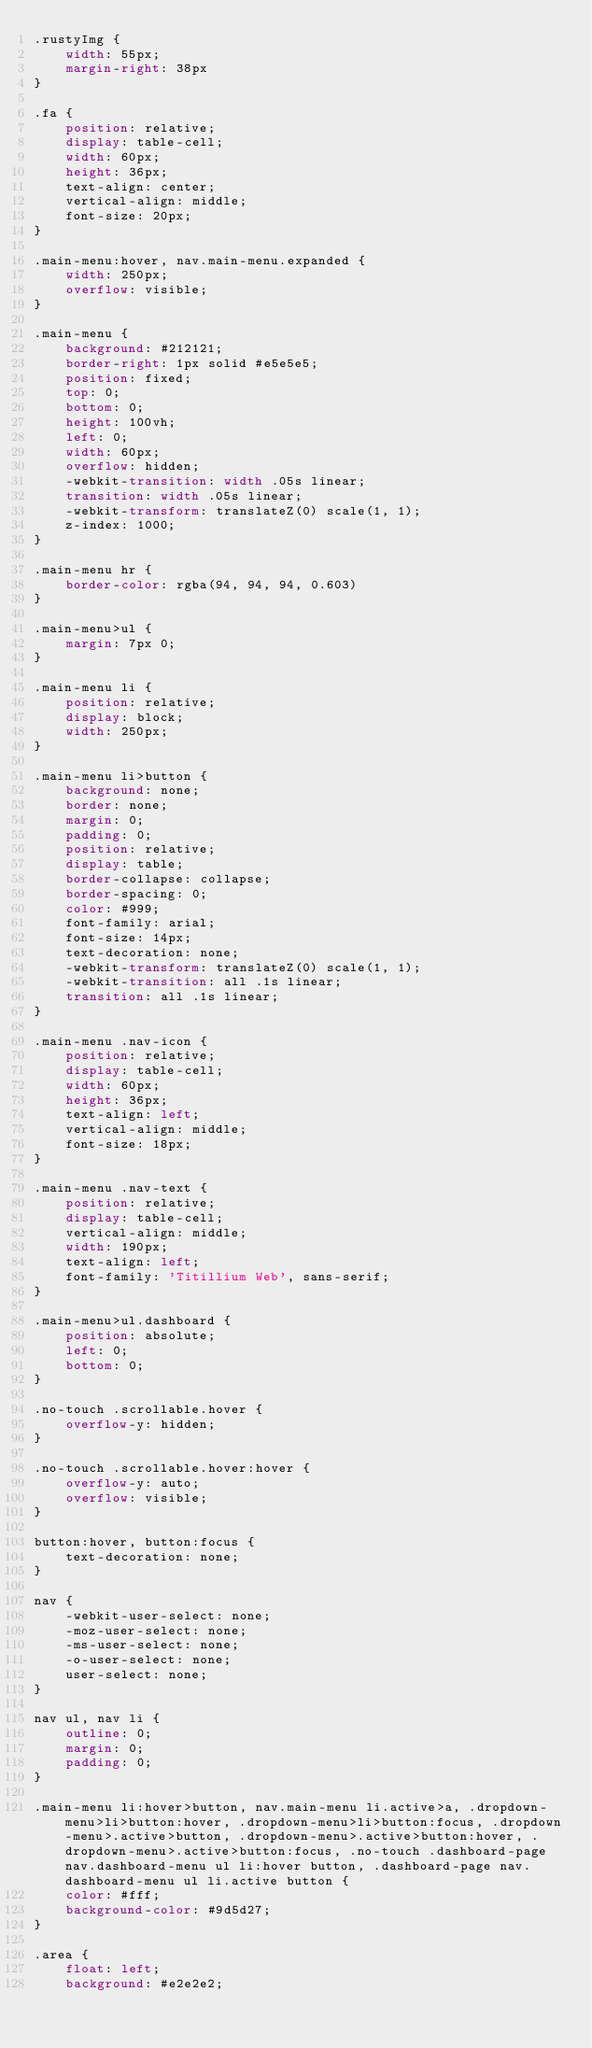<code> <loc_0><loc_0><loc_500><loc_500><_CSS_>.rustyImg {
    width: 55px;
    margin-right: 38px
}

.fa {
    position: relative;
    display: table-cell;
    width: 60px;
    height: 36px;
    text-align: center;
    vertical-align: middle;
    font-size: 20px;
}

.main-menu:hover, nav.main-menu.expanded {
    width: 250px;
    overflow: visible;
}

.main-menu {
    background: #212121;
    border-right: 1px solid #e5e5e5;
    position: fixed;
    top: 0;
    bottom: 0;
    height: 100vh;
    left: 0;
    width: 60px;
    overflow: hidden;
    -webkit-transition: width .05s linear;
    transition: width .05s linear;
    -webkit-transform: translateZ(0) scale(1, 1);
    z-index: 1000;
}

.main-menu hr {
    border-color: rgba(94, 94, 94, 0.603)
}

.main-menu>ul {
    margin: 7px 0;
}

.main-menu li {
    position: relative;
    display: block;
    width: 250px;
}

.main-menu li>button {
    background: none;
    border: none;
    margin: 0;
    padding: 0; 
    position: relative;
    display: table;
    border-collapse: collapse;
    border-spacing: 0;
    color: #999;
    font-family: arial;
    font-size: 14px;
    text-decoration: none;
    -webkit-transform: translateZ(0) scale(1, 1);
    -webkit-transition: all .1s linear;
    transition: all .1s linear;
}

.main-menu .nav-icon {
    position: relative;
    display: table-cell;
    width: 60px;
    height: 36px;
    text-align: left;
    vertical-align: middle;
    font-size: 18px;
}

.main-menu .nav-text {
    position: relative;
    display: table-cell;
    vertical-align: middle;
    width: 190px;
    text-align: left;
    font-family: 'Titillium Web', sans-serif;
}

.main-menu>ul.dashboard {
    position: absolute;
    left: 0;
    bottom: 0;
}

.no-touch .scrollable.hover {
    overflow-y: hidden;
}

.no-touch .scrollable.hover:hover {
    overflow-y: auto;
    overflow: visible;
}

button:hover, button:focus {
    text-decoration: none;
}

nav {
    -webkit-user-select: none;
    -moz-user-select: none;
    -ms-user-select: none;
    -o-user-select: none;
    user-select: none;
}

nav ul, nav li {
    outline: 0;
    margin: 0;
    padding: 0;
}

.main-menu li:hover>button, nav.main-menu li.active>a, .dropdown-menu>li>button:hover, .dropdown-menu>li>button:focus, .dropdown-menu>.active>button, .dropdown-menu>.active>button:hover, .dropdown-menu>.active>button:focus, .no-touch .dashboard-page nav.dashboard-menu ul li:hover button, .dashboard-page nav.dashboard-menu ul li.active button {
    color: #fff;
    background-color: #9d5d27;
}

.area {
    float: left;
    background: #e2e2e2;</code> 